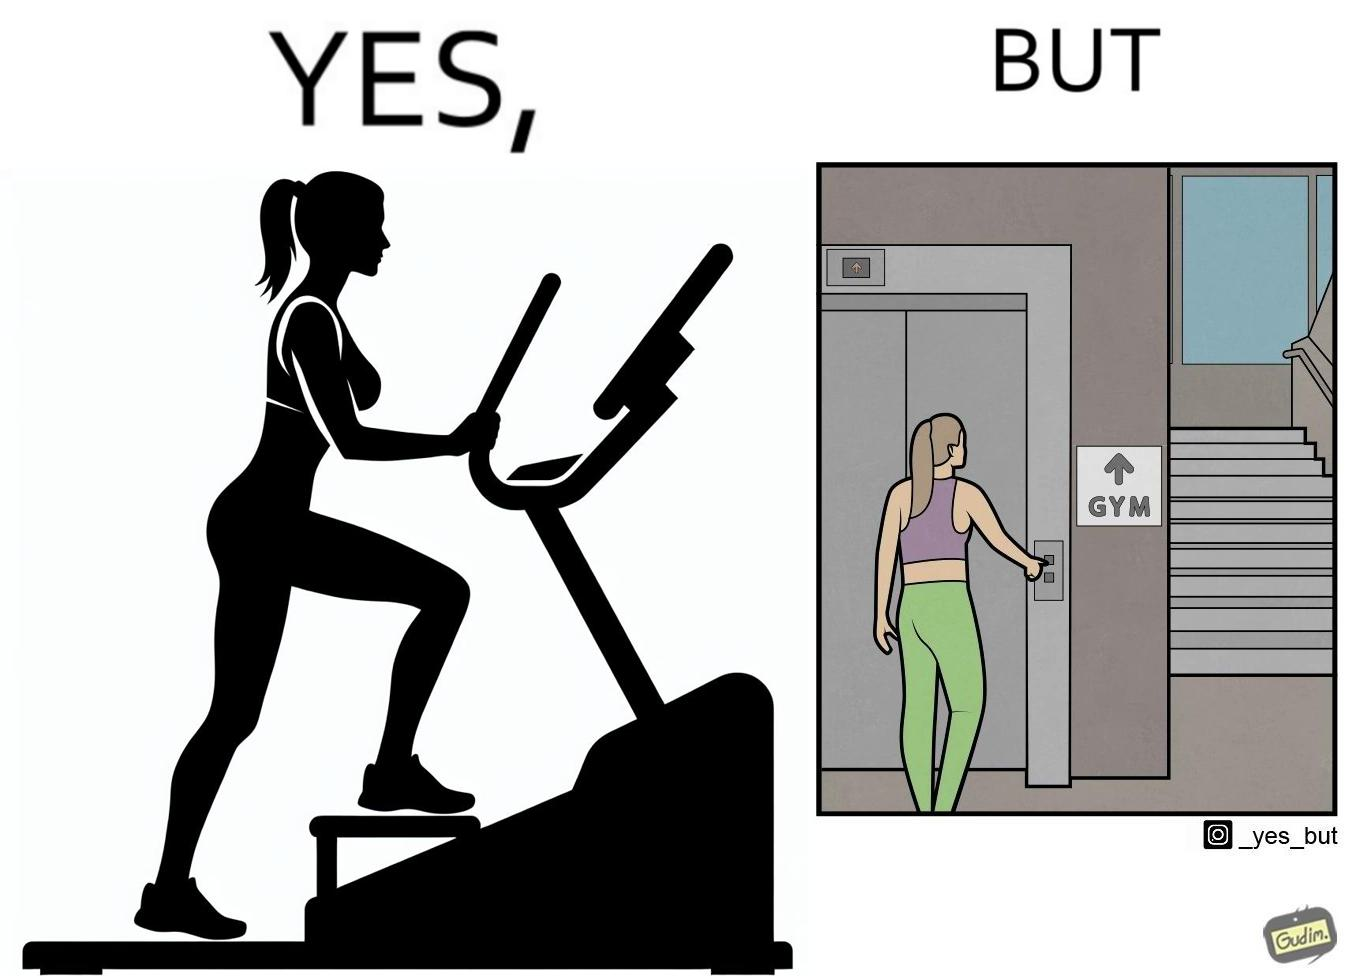Describe what you see in this image. The image is ironic, because in the left image a woman is seen using the stair climber machine at the gym but the same woman is not ready to climb up some stairs for going to the gym and is calling for the lift 